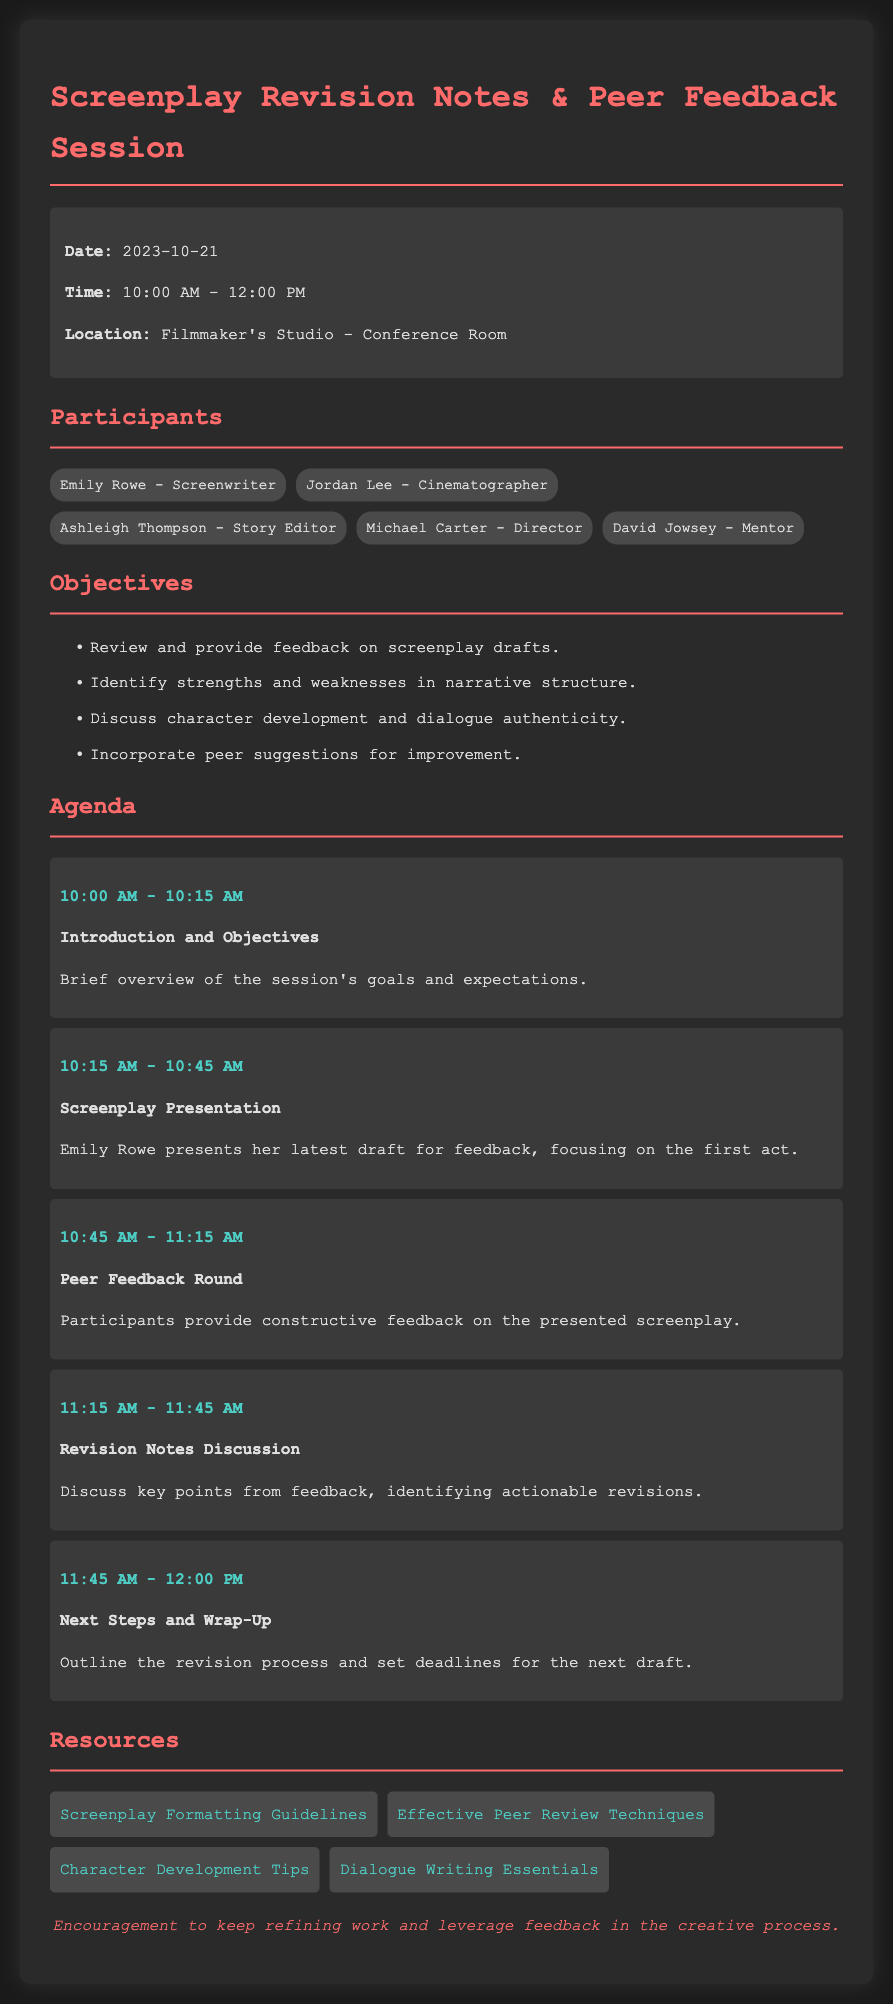What is the date of the session? The date is specifically mentioned at the start of the document as "2023-10-21."
Answer: 2023-10-21 Who is the director participating in the session? The participants are listed, including their roles, and Michael Carter is identified as the director.
Answer: Michael Carter What time does the screenplay presentation start? The agenda specifies time slots, with the screenplay presentation beginning at "10:15 AM."
Answer: 10:15 AM What is the main focus of Emily Rowe's presentation? The agenda item for Emily's presentation highlights that she will focus on "the first act" of her screenplay draft.
Answer: the first act How long is the Peer Feedback Round scheduled for? The duration of each agenda item is stated and the Peer Feedback Round is scheduled for "30 minutes."
Answer: 30 minutes What is one significant objective of the feedback session? The objectives list includes several goals, one of which is to "identify strengths and weaknesses in narrative structure."
Answer: identify strengths and weaknesses in narrative structure Which participant is noted as a mentor? The document specifies David Jowsey's role alongside others as a mentor.
Answer: David Jowsey What resource provides guidelines for screenplay formatting? The resources section includes a link to guidelines specifically focused on screenplay formatting identified as "Screenplay Formatting Guidelines."
Answer: Screenplay Formatting Guidelines 